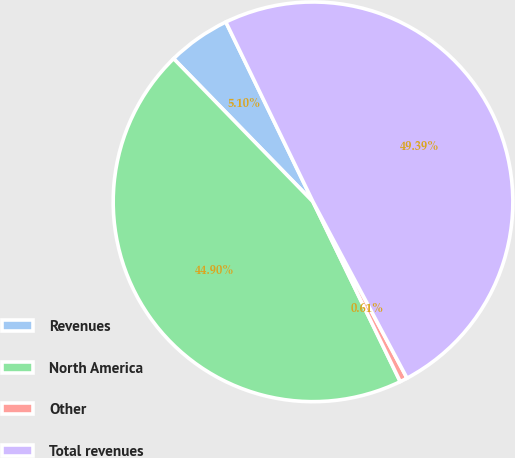<chart> <loc_0><loc_0><loc_500><loc_500><pie_chart><fcel>Revenues<fcel>North America<fcel>Other<fcel>Total revenues<nl><fcel>5.1%<fcel>44.9%<fcel>0.61%<fcel>49.39%<nl></chart> 